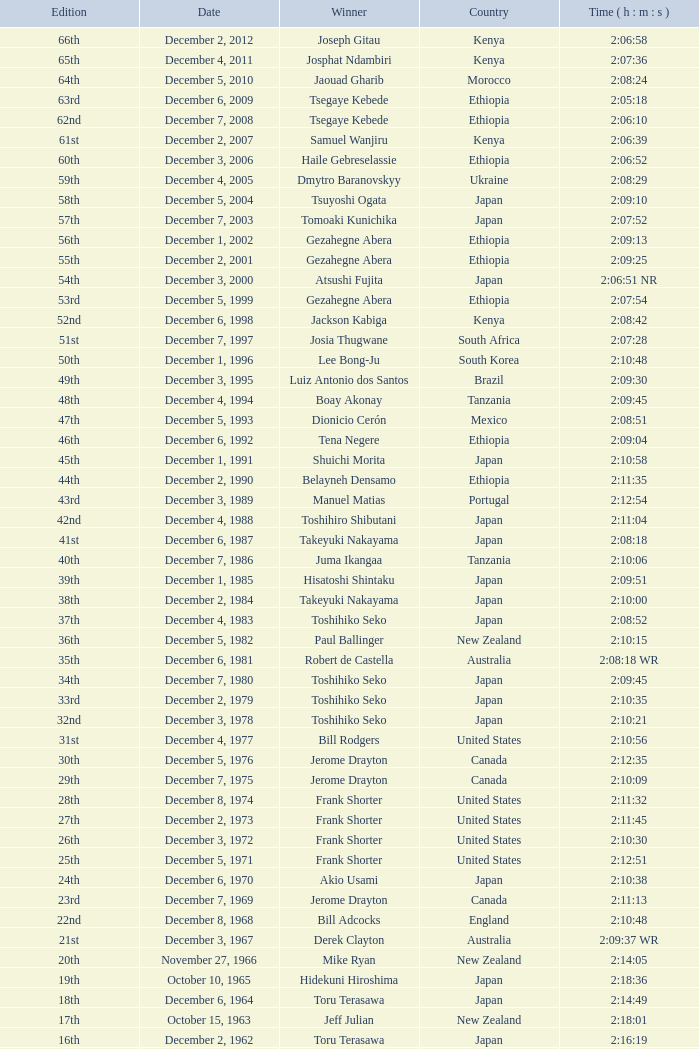What was the nationality of the winner for the 20th Edition? New Zealand. 